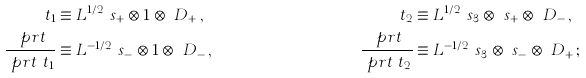<formula> <loc_0><loc_0><loc_500><loc_500>\ t _ { 1 } & \equiv L ^ { 1 / 2 } \ s _ { + } \otimes 1 \otimes \ D _ { + } \, , & \ t _ { 2 } & \equiv L ^ { 1 / 2 } \ s _ { 3 } \otimes \ s _ { + } \otimes \ D _ { - } \, , \\ \frac { \ p r t } { \ p r t \ t _ { 1 } } & \equiv L ^ { - 1 / 2 } \ s _ { - } \otimes 1 \otimes \ D _ { - } \, , & \frac { \ p r t } { \ p r t \ t _ { 2 } } & \equiv L ^ { - 1 / 2 } \ s _ { 3 } \otimes \ s _ { - } \otimes \ D _ { + } \, ;</formula> 